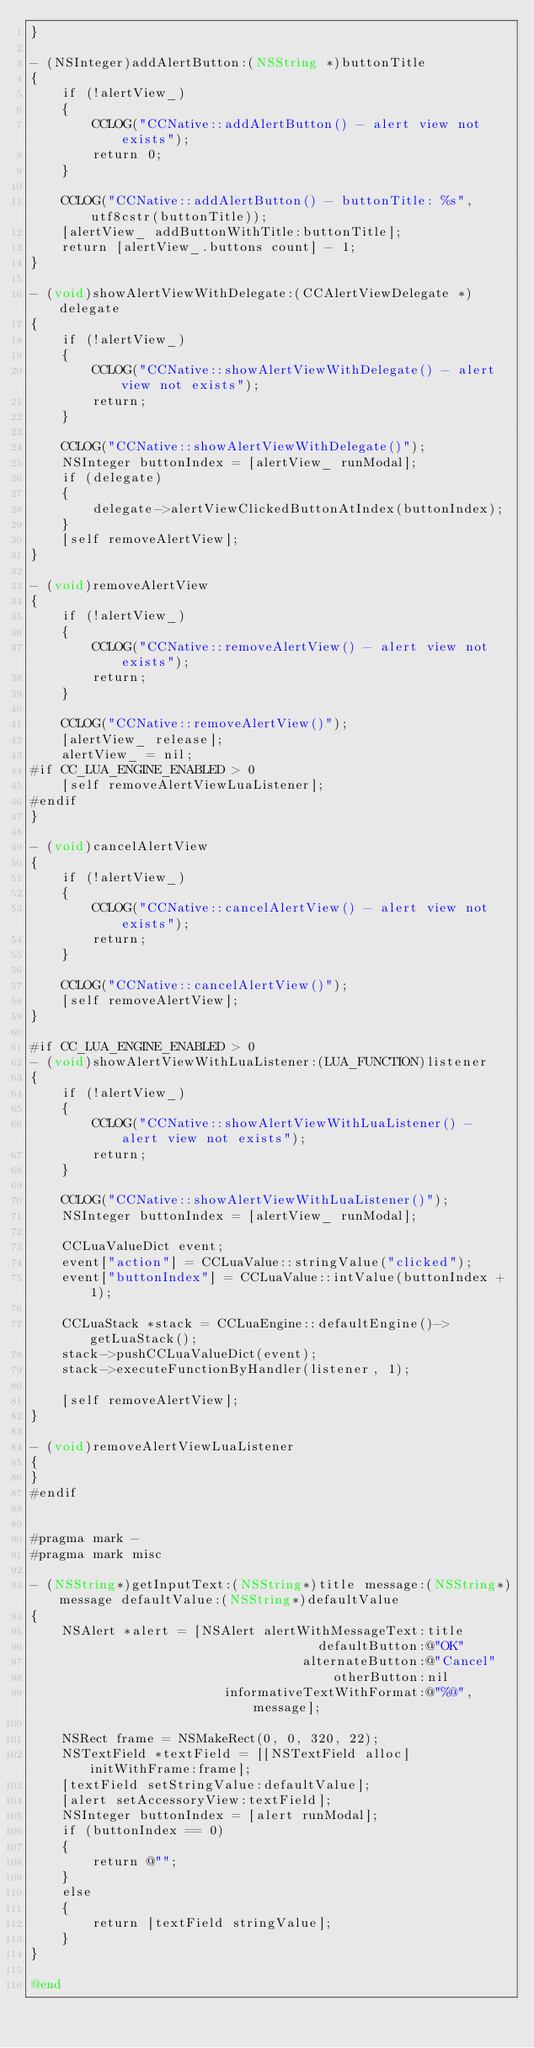Convert code to text. <code><loc_0><loc_0><loc_500><loc_500><_ObjectiveC_>}

- (NSInteger)addAlertButton:(NSString *)buttonTitle
{
    if (!alertView_)
    {
        CCLOG("CCNative::addAlertButton() - alert view not exists");
        return 0;
    }

    CCLOG("CCNative::addAlertButton() - buttonTitle: %s", utf8cstr(buttonTitle));
    [alertView_ addButtonWithTitle:buttonTitle];
    return [alertView_.buttons count] - 1;
}

- (void)showAlertViewWithDelegate:(CCAlertViewDelegate *)delegate
{
    if (!alertView_)
    {
        CCLOG("CCNative::showAlertViewWithDelegate() - alert view not exists");
        return;
    }

    CCLOG("CCNative::showAlertViewWithDelegate()");
    NSInteger buttonIndex = [alertView_ runModal];    
    if (delegate)
    {
        delegate->alertViewClickedButtonAtIndex(buttonIndex);
    }
    [self removeAlertView];
}

- (void)removeAlertView
{
    if (!alertView_)
    {
        CCLOG("CCNative::removeAlertView() - alert view not exists");
        return;
    }
    
    CCLOG("CCNative::removeAlertView()");
    [alertView_ release];
    alertView_ = nil;
#if CC_LUA_ENGINE_ENABLED > 0
    [self removeAlertViewLuaListener];
#endif
}

- (void)cancelAlertView
{
    if (!alertView_)
    {
        CCLOG("CCNative::cancelAlertView() - alert view not exists");
        return;
    }
    
    CCLOG("CCNative::cancelAlertView()");
    [self removeAlertView];
}

#if CC_LUA_ENGINE_ENABLED > 0
- (void)showAlertViewWithLuaListener:(LUA_FUNCTION)listener
{
    if (!alertView_)
    {
        CCLOG("CCNative::showAlertViewWithLuaListener() - alert view not exists");
        return;
    }
    
    CCLOG("CCNative::showAlertViewWithLuaListener()");
    NSInteger buttonIndex = [alertView_ runModal];
    
    CCLuaValueDict event;
    event["action"] = CCLuaValue::stringValue("clicked");
    event["buttonIndex"] = CCLuaValue::intValue(buttonIndex + 1);
    
    CCLuaStack *stack = CCLuaEngine::defaultEngine()->getLuaStack();
    stack->pushCCLuaValueDict(event);
    stack->executeFunctionByHandler(listener, 1);
    
    [self removeAlertView];
}

- (void)removeAlertViewLuaListener
{
}
#endif


#pragma mark -
#pragma mark misc

- (NSString*)getInputText:(NSString*)title message:(NSString*)message defaultValue:(NSString*)defaultValue
{
    NSAlert *alert = [NSAlert alertWithMessageText:title
                                     defaultButton:@"OK"
                                   alternateButton:@"Cancel"
                                       otherButton:nil
                         informativeTextWithFormat:@"%@", message];
    
    NSRect frame = NSMakeRect(0, 0, 320, 22);
    NSTextField *textField = [[NSTextField alloc] initWithFrame:frame];
    [textField setStringValue:defaultValue];
    [alert setAccessoryView:textField];
    NSInteger buttonIndex = [alert runModal];
    if (buttonIndex == 0)
    {
        return @"";
    }
    else
    {
        return [textField stringValue];
    }
}

@end
</code> 